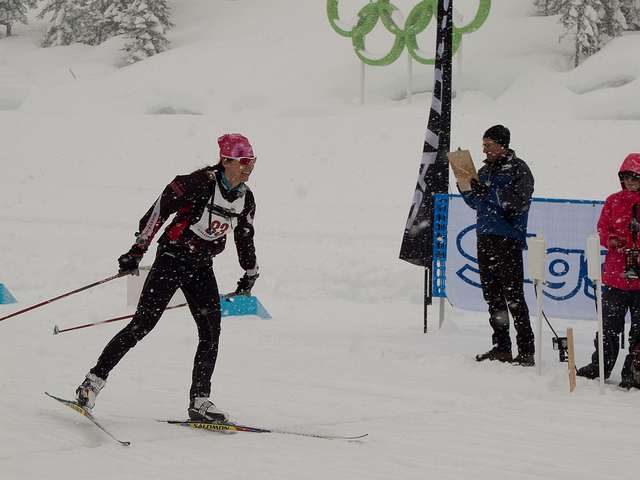<image>Which skier has the flashiest pants? It is ambiguous which skier has the flashiest pants. It could be the one on the left or none. Which skier has the flashiest pants? I am not sure which skier has the flashiest pants. 